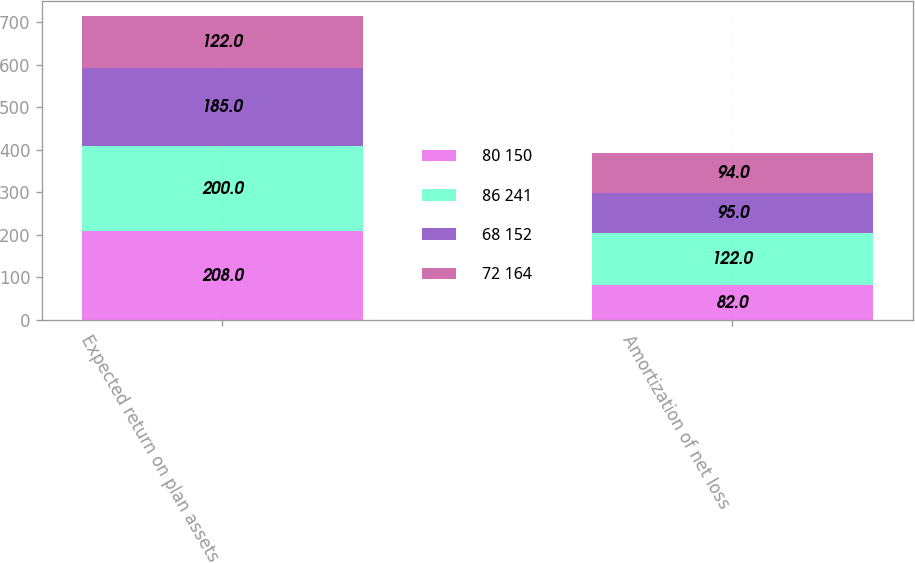<chart> <loc_0><loc_0><loc_500><loc_500><stacked_bar_chart><ecel><fcel>Expected return on plan assets<fcel>Amortization of net loss<nl><fcel>80 150<fcel>208<fcel>82<nl><fcel>86 241<fcel>200<fcel>122<nl><fcel>68 152<fcel>185<fcel>95<nl><fcel>72 164<fcel>122<fcel>94<nl></chart> 